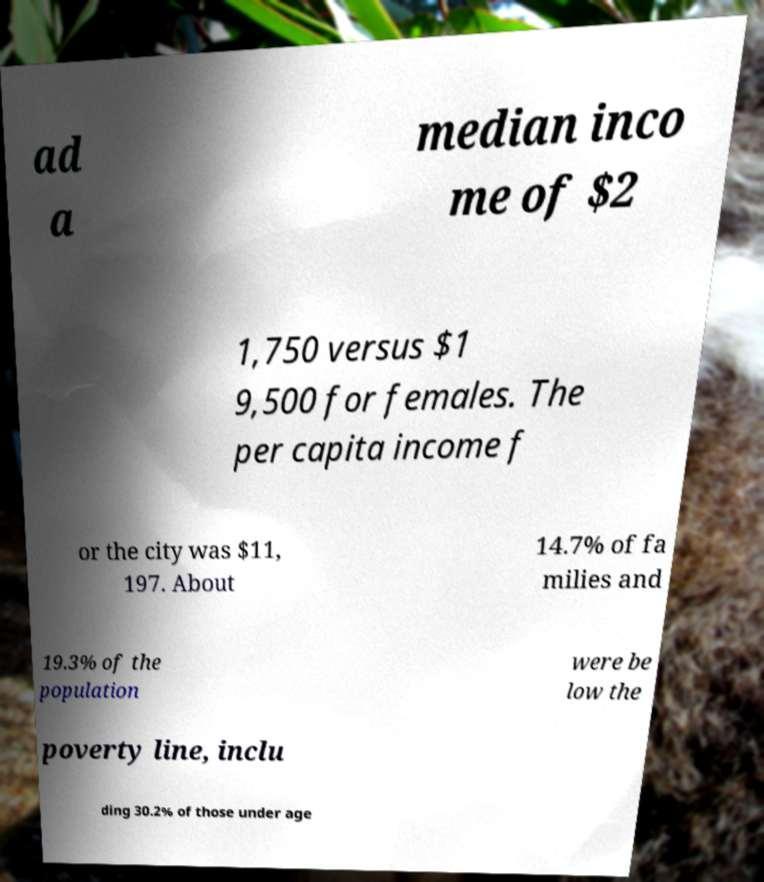There's text embedded in this image that I need extracted. Can you transcribe it verbatim? ad a median inco me of $2 1,750 versus $1 9,500 for females. The per capita income f or the city was $11, 197. About 14.7% of fa milies and 19.3% of the population were be low the poverty line, inclu ding 30.2% of those under age 